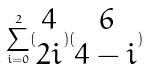Convert formula to latex. <formula><loc_0><loc_0><loc_500><loc_500>\sum _ { i = 0 } ^ { 2 } ( \begin{matrix} 4 \\ 2 i \end{matrix} ) ( \begin{matrix} 6 \\ 4 - i \end{matrix} )</formula> 